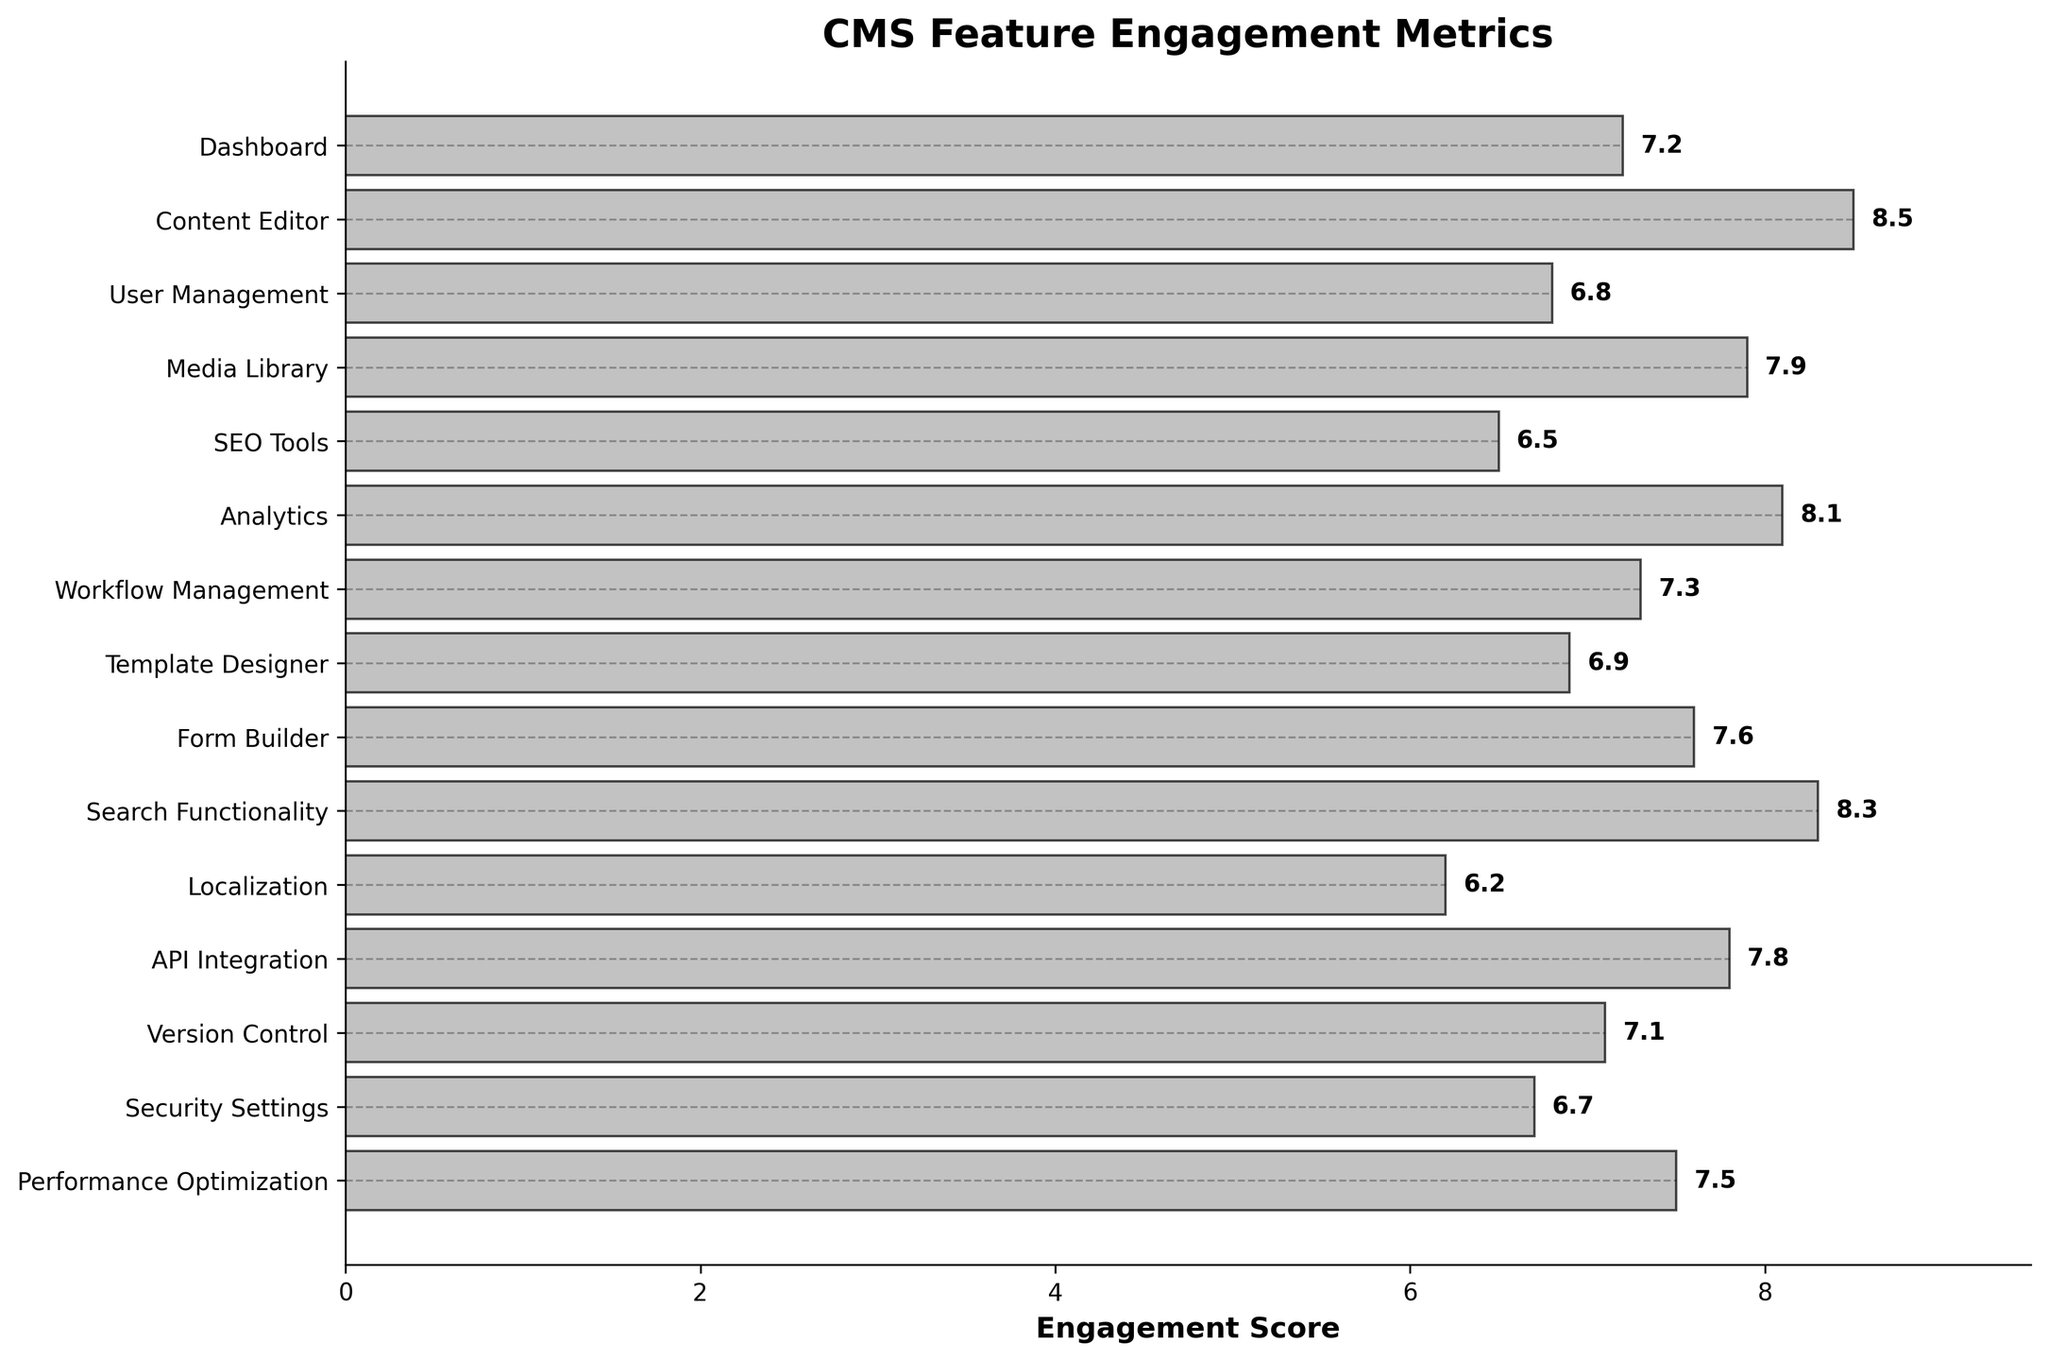What is the title of the figure? The title can be found at the top of the figure. It usually describes what the plot is about. In this case, the title is "CMS Feature Engagement Metrics".
Answer: CMS Feature Engagement Metrics What is the engagement score of the Analytics feature? The engagement scores are displayed at the end of each bar. For Analytics, the score is 8.1, as indicated by the label next to the Analytics bar.
Answer: 8.1 How many CMS features have an engagement score greater than 8? To find this, locate the bars with scores greater than 8 and count them. The features are "Content Editor", "Analytics", and "Search Functionality", totaling 3 features.
Answer: 3 Which feature has the lowest engagement score? The feature with the lowest engagement score will be the one at the end with the smallest value. "Localization" has the lowest score of 6.2.
Answer: Localization What is the average engagement score of all the features? Add all the engagement scores and divide by the number of features. (7.2 + 8.5 + 6.8 + 7.9 + 6.5 + 8.1 + 7.3 + 6.9 + 7.6 + 8.3 + 6.2 + 7.8 + 7.1 + 6.7 + 7.5) / 15 = 7.3
Answer: 7.3 Compare the engagement scores of "User Management" and "Security Settings". Which one is higher? Check the scores next to "User Management" and "Security Settings". "User Management" has a score of 6.8, and "Security Settings" has a score of 6.7. Therefore, "User Management" has a higher score.
Answer: User Management What is the difference in engagement scores between the "Content Editor" and "SEO Tools"? Subtract the engagement score of "SEO Tools" from "Content Editor": 8.5 - 6.5 = 2.0
Answer: 2.0 How many features have engagement scores between 7 and 8? Find and count the features that have scores within this range. They are "Dashboard", "Workflow Management", "Template Designer", "Form Builder", "API Integration", "Performance Optimization", and "Version Control", totaling 7 features.
Answer: 7 When looking at the plot, which axis represents the feature names? In a horizontal density plot, the y-axis typically represents the categorical variables, which are the feature names in this case.
Answer: y-axis 